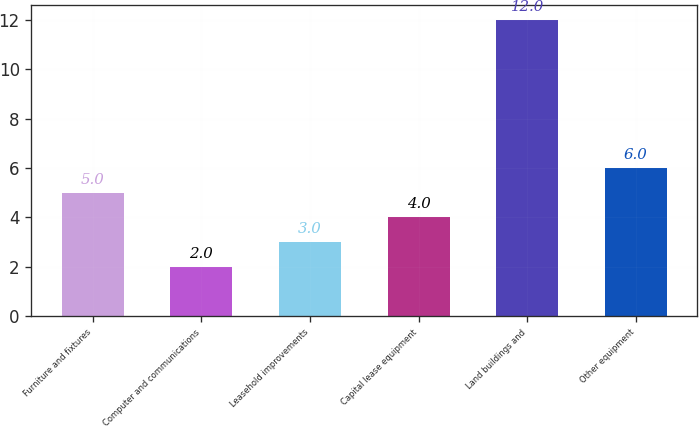<chart> <loc_0><loc_0><loc_500><loc_500><bar_chart><fcel>Furniture and fixtures<fcel>Computer and communications<fcel>Leasehold improvements<fcel>Capital lease equipment<fcel>Land buildings and<fcel>Other equipment<nl><fcel>5<fcel>2<fcel>3<fcel>4<fcel>12<fcel>6<nl></chart> 